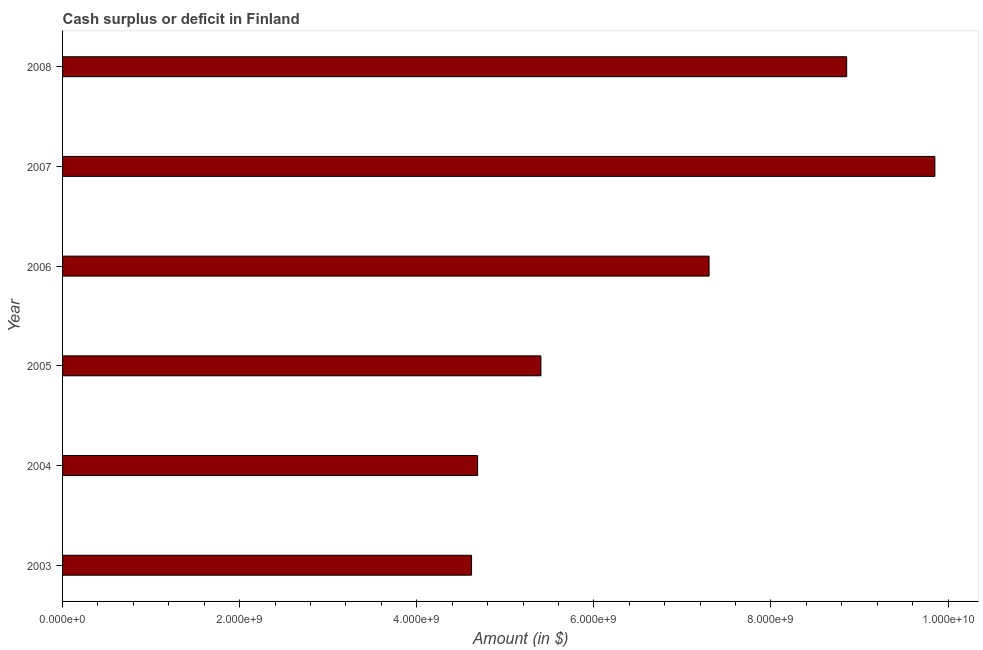Does the graph contain any zero values?
Ensure brevity in your answer.  No. What is the title of the graph?
Your answer should be compact. Cash surplus or deficit in Finland. What is the label or title of the X-axis?
Your answer should be very brief. Amount (in $). What is the label or title of the Y-axis?
Ensure brevity in your answer.  Year. What is the cash surplus or deficit in 2004?
Your answer should be compact. 4.69e+09. Across all years, what is the maximum cash surplus or deficit?
Provide a succinct answer. 9.85e+09. Across all years, what is the minimum cash surplus or deficit?
Keep it short and to the point. 4.62e+09. In which year was the cash surplus or deficit maximum?
Provide a succinct answer. 2007. What is the sum of the cash surplus or deficit?
Offer a terse response. 4.07e+1. What is the difference between the cash surplus or deficit in 2003 and 2007?
Make the answer very short. -5.23e+09. What is the average cash surplus or deficit per year?
Your response must be concise. 6.79e+09. What is the median cash surplus or deficit?
Give a very brief answer. 6.35e+09. In how many years, is the cash surplus or deficit greater than 2000000000 $?
Keep it short and to the point. 6. What is the ratio of the cash surplus or deficit in 2005 to that in 2008?
Give a very brief answer. 0.61. What is the difference between the highest and the second highest cash surplus or deficit?
Keep it short and to the point. 9.96e+08. What is the difference between the highest and the lowest cash surplus or deficit?
Offer a terse response. 5.23e+09. In how many years, is the cash surplus or deficit greater than the average cash surplus or deficit taken over all years?
Your answer should be very brief. 3. Are the values on the major ticks of X-axis written in scientific E-notation?
Provide a short and direct response. Yes. What is the Amount (in $) in 2003?
Keep it short and to the point. 4.62e+09. What is the Amount (in $) in 2004?
Keep it short and to the point. 4.69e+09. What is the Amount (in $) of 2005?
Your answer should be very brief. 5.40e+09. What is the Amount (in $) of 2006?
Offer a very short reply. 7.30e+09. What is the Amount (in $) in 2007?
Ensure brevity in your answer.  9.85e+09. What is the Amount (in $) in 2008?
Your answer should be compact. 8.86e+09. What is the difference between the Amount (in $) in 2003 and 2004?
Give a very brief answer. -6.80e+07. What is the difference between the Amount (in $) in 2003 and 2005?
Give a very brief answer. -7.83e+08. What is the difference between the Amount (in $) in 2003 and 2006?
Make the answer very short. -2.68e+09. What is the difference between the Amount (in $) in 2003 and 2007?
Your response must be concise. -5.23e+09. What is the difference between the Amount (in $) in 2003 and 2008?
Ensure brevity in your answer.  -4.24e+09. What is the difference between the Amount (in $) in 2004 and 2005?
Your answer should be very brief. -7.15e+08. What is the difference between the Amount (in $) in 2004 and 2006?
Your answer should be compact. -2.61e+09. What is the difference between the Amount (in $) in 2004 and 2007?
Provide a short and direct response. -5.16e+09. What is the difference between the Amount (in $) in 2004 and 2008?
Your response must be concise. -4.17e+09. What is the difference between the Amount (in $) in 2005 and 2006?
Offer a terse response. -1.90e+09. What is the difference between the Amount (in $) in 2005 and 2007?
Your answer should be very brief. -4.45e+09. What is the difference between the Amount (in $) in 2005 and 2008?
Provide a succinct answer. -3.45e+09. What is the difference between the Amount (in $) in 2006 and 2007?
Offer a very short reply. -2.55e+09. What is the difference between the Amount (in $) in 2006 and 2008?
Your response must be concise. -1.55e+09. What is the difference between the Amount (in $) in 2007 and 2008?
Keep it short and to the point. 9.96e+08. What is the ratio of the Amount (in $) in 2003 to that in 2005?
Provide a short and direct response. 0.85. What is the ratio of the Amount (in $) in 2003 to that in 2006?
Your answer should be very brief. 0.63. What is the ratio of the Amount (in $) in 2003 to that in 2007?
Your answer should be very brief. 0.47. What is the ratio of the Amount (in $) in 2003 to that in 2008?
Your answer should be very brief. 0.52. What is the ratio of the Amount (in $) in 2004 to that in 2005?
Provide a succinct answer. 0.87. What is the ratio of the Amount (in $) in 2004 to that in 2006?
Keep it short and to the point. 0.64. What is the ratio of the Amount (in $) in 2004 to that in 2007?
Provide a succinct answer. 0.48. What is the ratio of the Amount (in $) in 2004 to that in 2008?
Your answer should be compact. 0.53. What is the ratio of the Amount (in $) in 2005 to that in 2006?
Your answer should be compact. 0.74. What is the ratio of the Amount (in $) in 2005 to that in 2007?
Keep it short and to the point. 0.55. What is the ratio of the Amount (in $) in 2005 to that in 2008?
Make the answer very short. 0.61. What is the ratio of the Amount (in $) in 2006 to that in 2007?
Provide a succinct answer. 0.74. What is the ratio of the Amount (in $) in 2006 to that in 2008?
Provide a succinct answer. 0.82. What is the ratio of the Amount (in $) in 2007 to that in 2008?
Give a very brief answer. 1.11. 